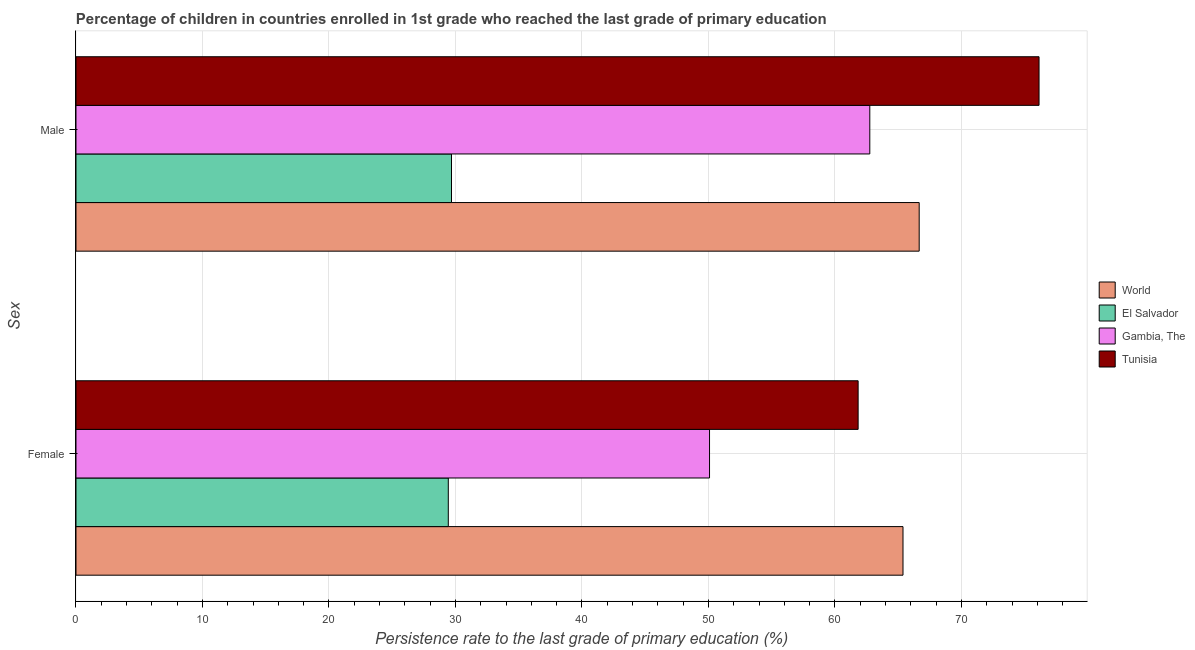How many groups of bars are there?
Offer a terse response. 2. Are the number of bars per tick equal to the number of legend labels?
Make the answer very short. Yes. How many bars are there on the 1st tick from the top?
Give a very brief answer. 4. How many bars are there on the 1st tick from the bottom?
Offer a very short reply. 4. What is the label of the 2nd group of bars from the top?
Keep it short and to the point. Female. What is the persistence rate of female students in El Salvador?
Provide a short and direct response. 29.43. Across all countries, what is the maximum persistence rate of female students?
Provide a succinct answer. 65.38. Across all countries, what is the minimum persistence rate of male students?
Give a very brief answer. 29.69. In which country was the persistence rate of male students maximum?
Provide a short and direct response. Tunisia. In which country was the persistence rate of male students minimum?
Offer a very short reply. El Salvador. What is the total persistence rate of male students in the graph?
Provide a short and direct response. 235.23. What is the difference between the persistence rate of male students in Tunisia and that in El Salvador?
Your answer should be compact. 46.45. What is the difference between the persistence rate of female students in World and the persistence rate of male students in El Salvador?
Provide a succinct answer. 35.69. What is the average persistence rate of female students per country?
Offer a terse response. 51.68. What is the difference between the persistence rate of male students and persistence rate of female students in Gambia, The?
Keep it short and to the point. 12.67. What is the ratio of the persistence rate of male students in World to that in Gambia, The?
Your response must be concise. 1.06. In how many countries, is the persistence rate of female students greater than the average persistence rate of female students taken over all countries?
Your answer should be compact. 2. What does the 2nd bar from the top in Female represents?
Give a very brief answer. Gambia, The. What does the 2nd bar from the bottom in Female represents?
Give a very brief answer. El Salvador. How many bars are there?
Your answer should be very brief. 8. How many countries are there in the graph?
Your answer should be very brief. 4. What is the difference between two consecutive major ticks on the X-axis?
Provide a succinct answer. 10. Are the values on the major ticks of X-axis written in scientific E-notation?
Make the answer very short. No. What is the title of the graph?
Your response must be concise. Percentage of children in countries enrolled in 1st grade who reached the last grade of primary education. Does "India" appear as one of the legend labels in the graph?
Provide a short and direct response. No. What is the label or title of the X-axis?
Offer a very short reply. Persistence rate to the last grade of primary education (%). What is the label or title of the Y-axis?
Provide a short and direct response. Sex. What is the Persistence rate to the last grade of primary education (%) in World in Female?
Provide a succinct answer. 65.38. What is the Persistence rate to the last grade of primary education (%) in El Salvador in Female?
Offer a terse response. 29.43. What is the Persistence rate to the last grade of primary education (%) of Gambia, The in Female?
Your answer should be compact. 50.08. What is the Persistence rate to the last grade of primary education (%) of Tunisia in Female?
Provide a succinct answer. 61.83. What is the Persistence rate to the last grade of primary education (%) in World in Male?
Offer a terse response. 66.66. What is the Persistence rate to the last grade of primary education (%) of El Salvador in Male?
Your response must be concise. 29.69. What is the Persistence rate to the last grade of primary education (%) of Gambia, The in Male?
Your response must be concise. 62.75. What is the Persistence rate to the last grade of primary education (%) of Tunisia in Male?
Give a very brief answer. 76.13. Across all Sex, what is the maximum Persistence rate to the last grade of primary education (%) in World?
Your response must be concise. 66.66. Across all Sex, what is the maximum Persistence rate to the last grade of primary education (%) of El Salvador?
Keep it short and to the point. 29.69. Across all Sex, what is the maximum Persistence rate to the last grade of primary education (%) in Gambia, The?
Provide a succinct answer. 62.75. Across all Sex, what is the maximum Persistence rate to the last grade of primary education (%) in Tunisia?
Make the answer very short. 76.13. Across all Sex, what is the minimum Persistence rate to the last grade of primary education (%) of World?
Offer a very short reply. 65.38. Across all Sex, what is the minimum Persistence rate to the last grade of primary education (%) of El Salvador?
Offer a terse response. 29.43. Across all Sex, what is the minimum Persistence rate to the last grade of primary education (%) of Gambia, The?
Your answer should be compact. 50.08. Across all Sex, what is the minimum Persistence rate to the last grade of primary education (%) of Tunisia?
Give a very brief answer. 61.83. What is the total Persistence rate to the last grade of primary education (%) in World in the graph?
Offer a very short reply. 132.04. What is the total Persistence rate to the last grade of primary education (%) in El Salvador in the graph?
Your answer should be compact. 59.12. What is the total Persistence rate to the last grade of primary education (%) of Gambia, The in the graph?
Provide a short and direct response. 112.84. What is the total Persistence rate to the last grade of primary education (%) of Tunisia in the graph?
Your response must be concise. 137.96. What is the difference between the Persistence rate to the last grade of primary education (%) in World in Female and that in Male?
Make the answer very short. -1.28. What is the difference between the Persistence rate to the last grade of primary education (%) in El Salvador in Female and that in Male?
Offer a very short reply. -0.25. What is the difference between the Persistence rate to the last grade of primary education (%) of Gambia, The in Female and that in Male?
Offer a terse response. -12.67. What is the difference between the Persistence rate to the last grade of primary education (%) of Tunisia in Female and that in Male?
Your answer should be very brief. -14.3. What is the difference between the Persistence rate to the last grade of primary education (%) in World in Female and the Persistence rate to the last grade of primary education (%) in El Salvador in Male?
Keep it short and to the point. 35.69. What is the difference between the Persistence rate to the last grade of primary education (%) of World in Female and the Persistence rate to the last grade of primary education (%) of Gambia, The in Male?
Offer a terse response. 2.62. What is the difference between the Persistence rate to the last grade of primary education (%) of World in Female and the Persistence rate to the last grade of primary education (%) of Tunisia in Male?
Provide a short and direct response. -10.75. What is the difference between the Persistence rate to the last grade of primary education (%) in El Salvador in Female and the Persistence rate to the last grade of primary education (%) in Gambia, The in Male?
Ensure brevity in your answer.  -33.32. What is the difference between the Persistence rate to the last grade of primary education (%) in El Salvador in Female and the Persistence rate to the last grade of primary education (%) in Tunisia in Male?
Provide a succinct answer. -46.7. What is the difference between the Persistence rate to the last grade of primary education (%) of Gambia, The in Female and the Persistence rate to the last grade of primary education (%) of Tunisia in Male?
Provide a succinct answer. -26.05. What is the average Persistence rate to the last grade of primary education (%) of World per Sex?
Your answer should be compact. 66.02. What is the average Persistence rate to the last grade of primary education (%) in El Salvador per Sex?
Offer a terse response. 29.56. What is the average Persistence rate to the last grade of primary education (%) in Gambia, The per Sex?
Ensure brevity in your answer.  56.42. What is the average Persistence rate to the last grade of primary education (%) of Tunisia per Sex?
Give a very brief answer. 68.98. What is the difference between the Persistence rate to the last grade of primary education (%) of World and Persistence rate to the last grade of primary education (%) of El Salvador in Female?
Your answer should be compact. 35.95. What is the difference between the Persistence rate to the last grade of primary education (%) in World and Persistence rate to the last grade of primary education (%) in Gambia, The in Female?
Keep it short and to the point. 15.29. What is the difference between the Persistence rate to the last grade of primary education (%) in World and Persistence rate to the last grade of primary education (%) in Tunisia in Female?
Provide a short and direct response. 3.55. What is the difference between the Persistence rate to the last grade of primary education (%) in El Salvador and Persistence rate to the last grade of primary education (%) in Gambia, The in Female?
Make the answer very short. -20.65. What is the difference between the Persistence rate to the last grade of primary education (%) in El Salvador and Persistence rate to the last grade of primary education (%) in Tunisia in Female?
Your answer should be very brief. -32.4. What is the difference between the Persistence rate to the last grade of primary education (%) in Gambia, The and Persistence rate to the last grade of primary education (%) in Tunisia in Female?
Offer a terse response. -11.75. What is the difference between the Persistence rate to the last grade of primary education (%) in World and Persistence rate to the last grade of primary education (%) in El Salvador in Male?
Offer a terse response. 36.97. What is the difference between the Persistence rate to the last grade of primary education (%) in World and Persistence rate to the last grade of primary education (%) in Gambia, The in Male?
Ensure brevity in your answer.  3.9. What is the difference between the Persistence rate to the last grade of primary education (%) in World and Persistence rate to the last grade of primary education (%) in Tunisia in Male?
Offer a very short reply. -9.48. What is the difference between the Persistence rate to the last grade of primary education (%) of El Salvador and Persistence rate to the last grade of primary education (%) of Gambia, The in Male?
Offer a terse response. -33.07. What is the difference between the Persistence rate to the last grade of primary education (%) of El Salvador and Persistence rate to the last grade of primary education (%) of Tunisia in Male?
Your answer should be compact. -46.45. What is the difference between the Persistence rate to the last grade of primary education (%) of Gambia, The and Persistence rate to the last grade of primary education (%) of Tunisia in Male?
Your answer should be very brief. -13.38. What is the ratio of the Persistence rate to the last grade of primary education (%) in World in Female to that in Male?
Your answer should be very brief. 0.98. What is the ratio of the Persistence rate to the last grade of primary education (%) in Gambia, The in Female to that in Male?
Make the answer very short. 0.8. What is the ratio of the Persistence rate to the last grade of primary education (%) in Tunisia in Female to that in Male?
Make the answer very short. 0.81. What is the difference between the highest and the second highest Persistence rate to the last grade of primary education (%) of World?
Ensure brevity in your answer.  1.28. What is the difference between the highest and the second highest Persistence rate to the last grade of primary education (%) of El Salvador?
Ensure brevity in your answer.  0.25. What is the difference between the highest and the second highest Persistence rate to the last grade of primary education (%) of Gambia, The?
Keep it short and to the point. 12.67. What is the difference between the highest and the second highest Persistence rate to the last grade of primary education (%) in Tunisia?
Your response must be concise. 14.3. What is the difference between the highest and the lowest Persistence rate to the last grade of primary education (%) of World?
Provide a succinct answer. 1.28. What is the difference between the highest and the lowest Persistence rate to the last grade of primary education (%) of El Salvador?
Your answer should be very brief. 0.25. What is the difference between the highest and the lowest Persistence rate to the last grade of primary education (%) of Gambia, The?
Provide a short and direct response. 12.67. What is the difference between the highest and the lowest Persistence rate to the last grade of primary education (%) in Tunisia?
Ensure brevity in your answer.  14.3. 